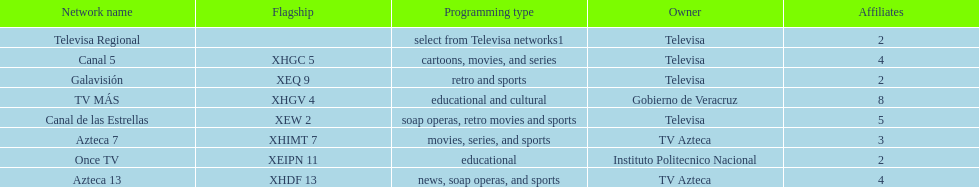Which is the only station with 8 affiliates? TV MÁS. Would you mind parsing the complete table? {'header': ['Network name', 'Flagship', 'Programming type', 'Owner', 'Affiliates'], 'rows': [['Televisa Regional', '', 'select from Televisa networks1', 'Televisa', '2'], ['Canal 5', 'XHGC 5', 'cartoons, movies, and series', 'Televisa', '4'], ['Galavisión', 'XEQ 9', 'retro and sports', 'Televisa', '2'], ['TV MÁS', 'XHGV 4', 'educational and cultural', 'Gobierno de Veracruz', '8'], ['Canal de las Estrellas', 'XEW 2', 'soap operas, retro movies and sports', 'Televisa', '5'], ['Azteca 7', 'XHIMT 7', 'movies, series, and sports', 'TV Azteca', '3'], ['Once TV', 'XEIPN 11', 'educational', 'Instituto Politecnico Nacional', '2'], ['Azteca 13', 'XHDF 13', 'news, soap operas, and sports', 'TV Azteca', '4']]} 